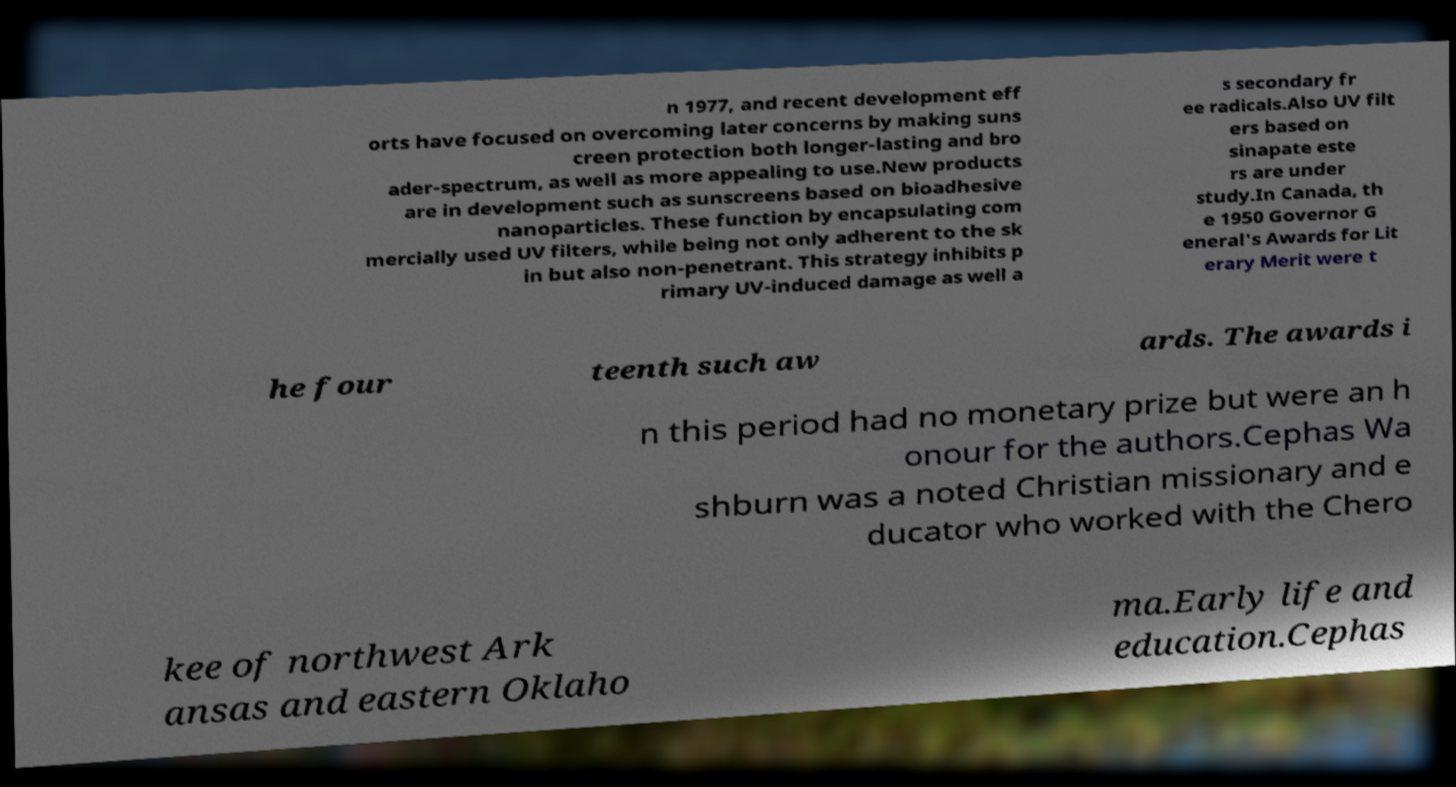I need the written content from this picture converted into text. Can you do that? n 1977, and recent development eff orts have focused on overcoming later concerns by making suns creen protection both longer-lasting and bro ader-spectrum, as well as more appealing to use.New products are in development such as sunscreens based on bioadhesive nanoparticles. These function by encapsulating com mercially used UV filters, while being not only adherent to the sk in but also non-penetrant. This strategy inhibits p rimary UV-induced damage as well a s secondary fr ee radicals.Also UV filt ers based on sinapate este rs are under study.In Canada, th e 1950 Governor G eneral's Awards for Lit erary Merit were t he four teenth such aw ards. The awards i n this period had no monetary prize but were an h onour for the authors.Cephas Wa shburn was a noted Christian missionary and e ducator who worked with the Chero kee of northwest Ark ansas and eastern Oklaho ma.Early life and education.Cephas 